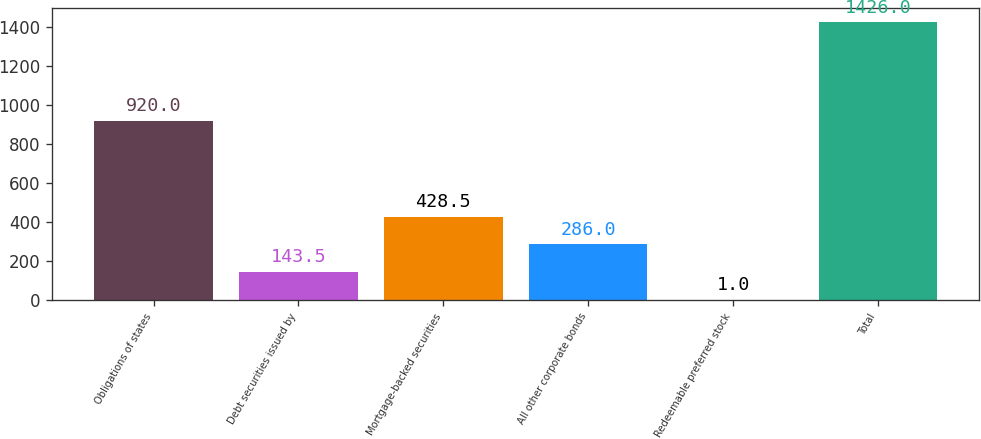Convert chart to OTSL. <chart><loc_0><loc_0><loc_500><loc_500><bar_chart><fcel>Obligations of states<fcel>Debt securities issued by<fcel>Mortgage-backed securities<fcel>All other corporate bonds<fcel>Redeemable preferred stock<fcel>Total<nl><fcel>920<fcel>143.5<fcel>428.5<fcel>286<fcel>1<fcel>1426<nl></chart> 